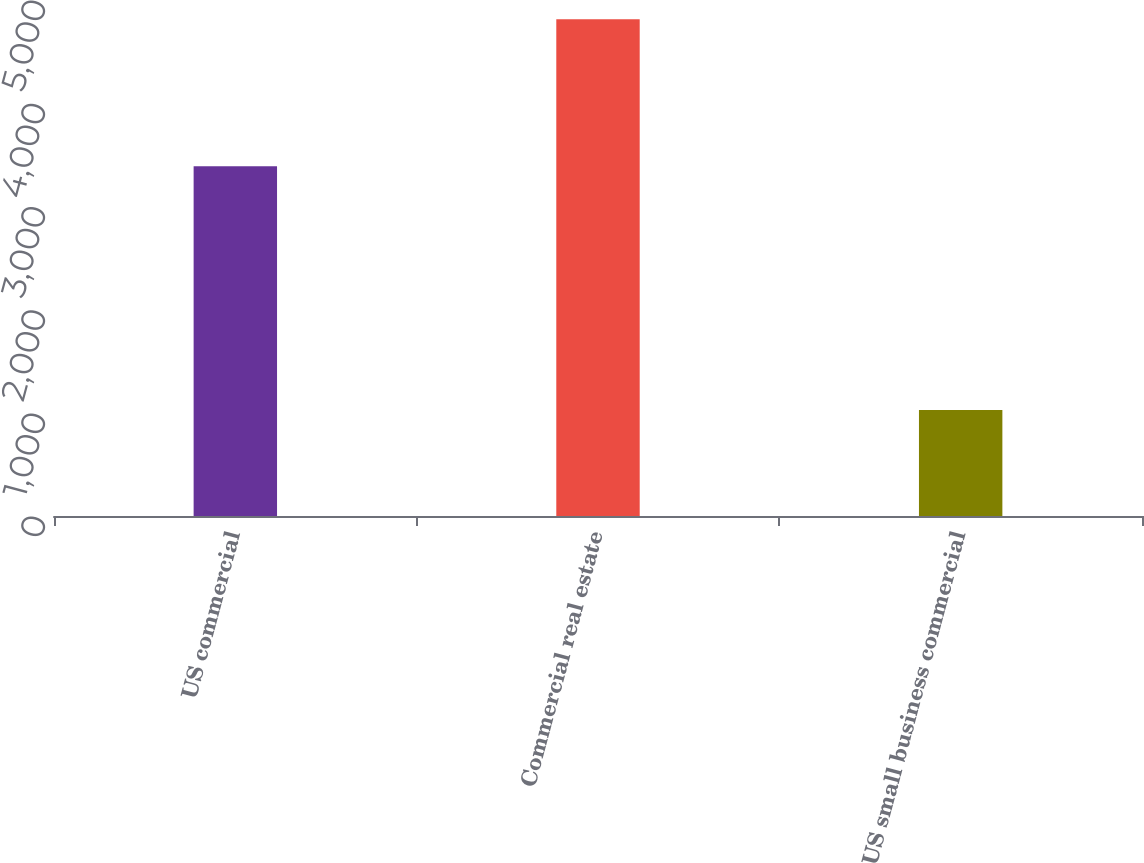Convert chart to OTSL. <chart><loc_0><loc_0><loc_500><loc_500><bar_chart><fcel>US commercial<fcel>Commercial real estate<fcel>US small business commercial<nl><fcel>3389<fcel>4813<fcel>1028<nl></chart> 